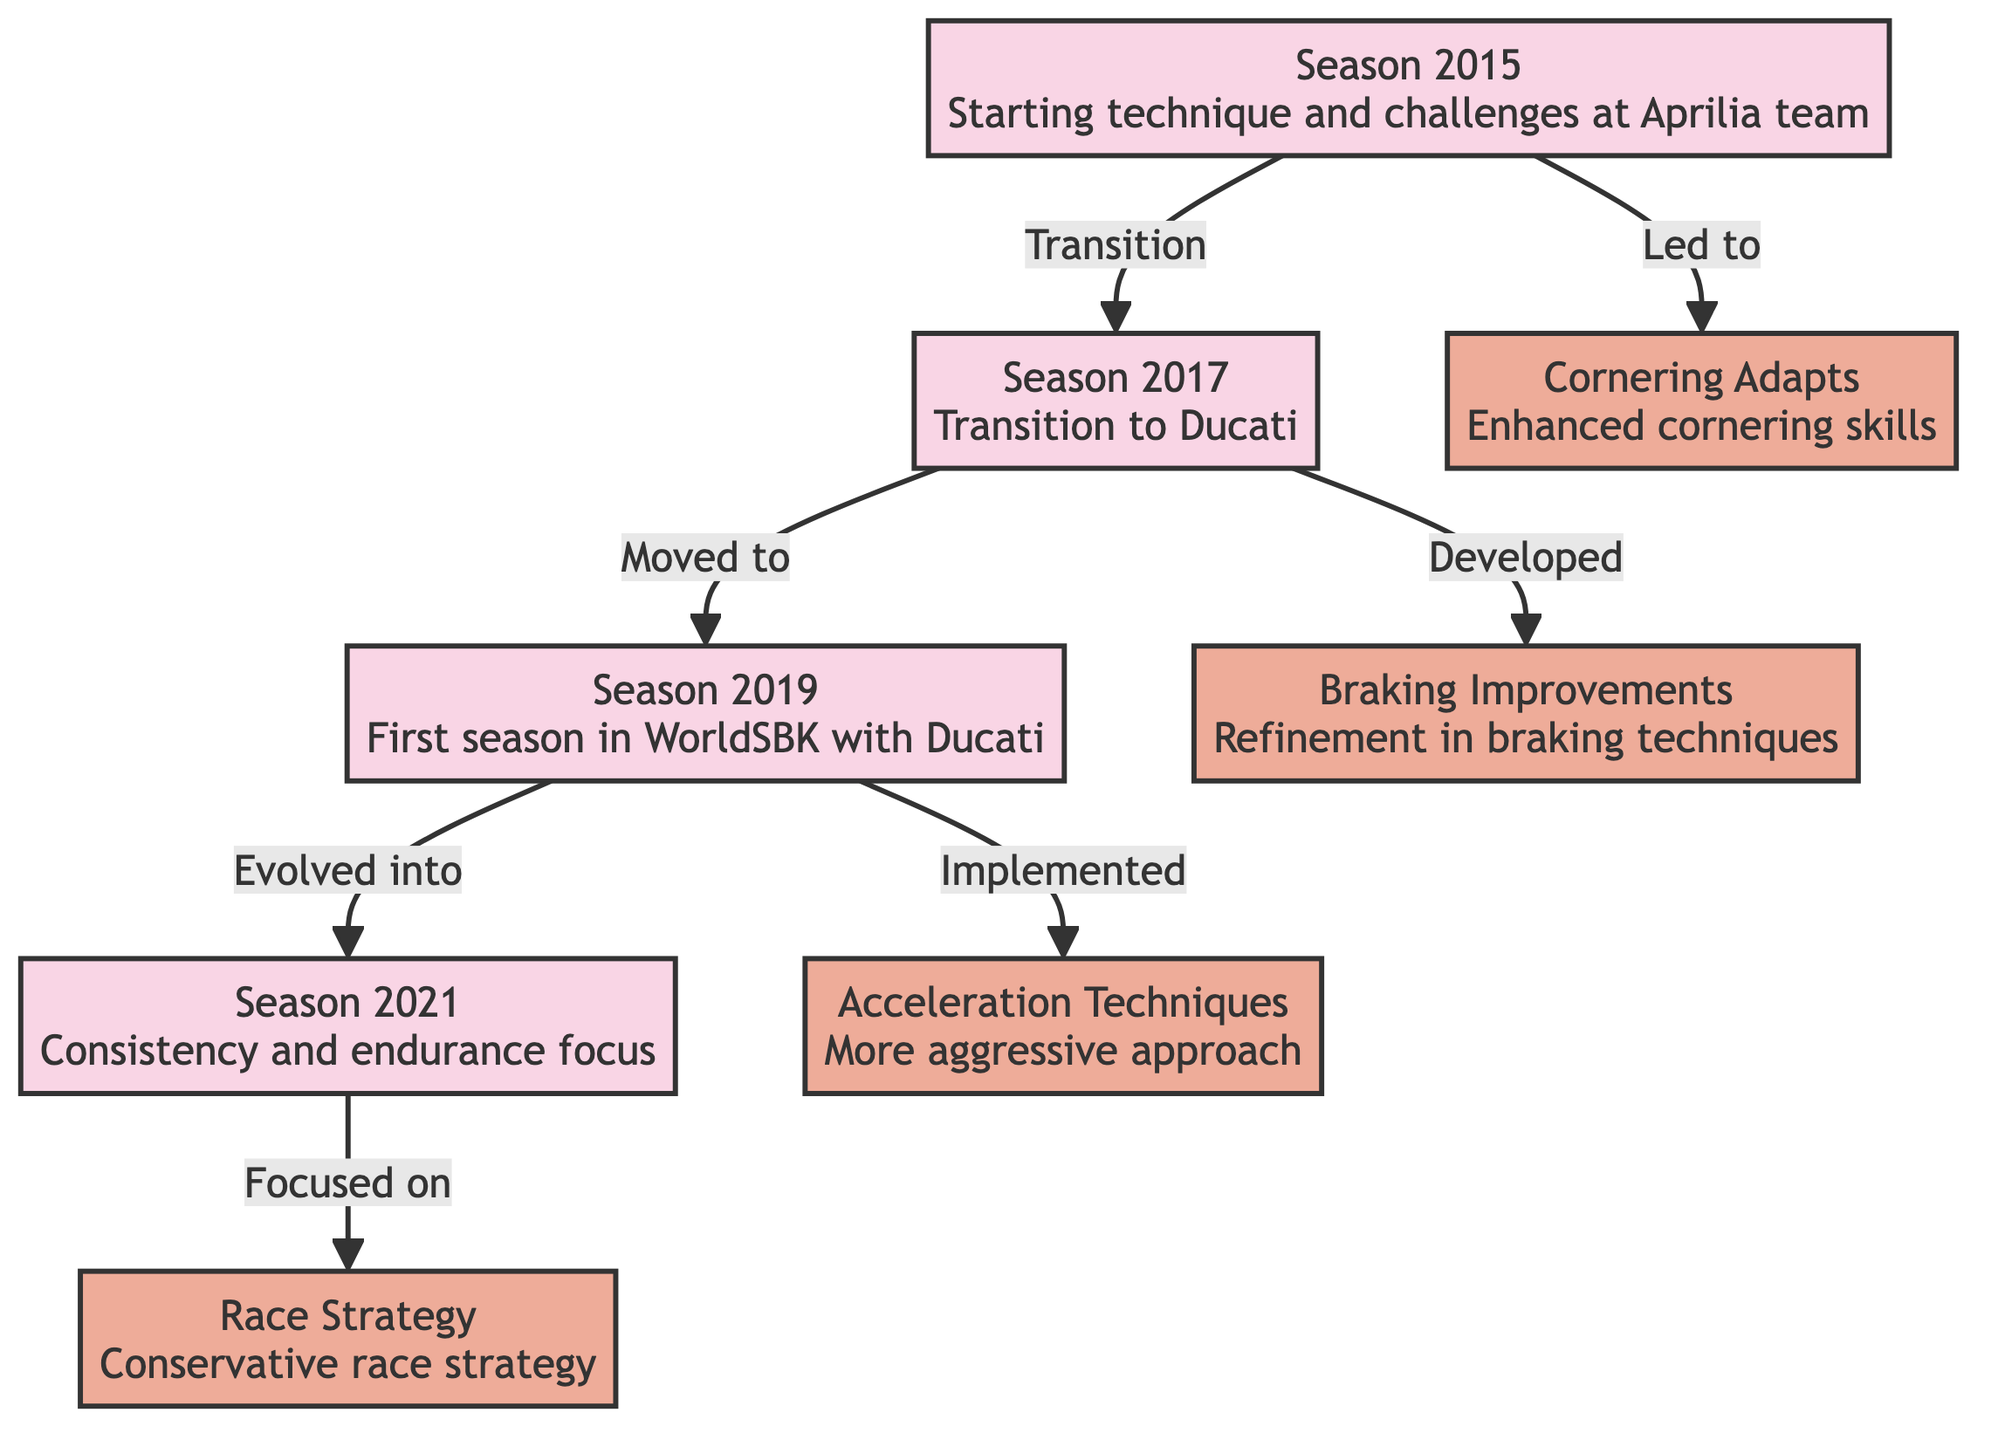What's the primary focus of Season 2015? The diagram states that Season 2015 is characterized by "Starting technique and challenges at Aprilia team". Thus, the primary focus is on the initial development and struggles faced by Bautista during this year.
Answer: Starting technique and challenges at Aprilia team How many seasons are represented in the diagram? The diagram has four distinct nodes labeled as seasons: Season 2015, Season 2017, Adaptation 2019, and Consistency 2021. Counting these gives a total of four seasons.
Answer: 4 Which technique was developed in Season 2017? The edge from Season 2017 to Braking Improvements indicates that this technique was specifically developed during that season, focusing on refinement in braking techniques.
Answer: Braking Improvements What adaptation did Álvaro Bautista implement in 2019? The arrow from Adaptation 2019 to Acceleration Techniques indicates that he implemented a more aggressive acceleration approach and a quick shift technique during that season.
Answer: Acceleration Techniques How does Consistency 2021 relate to Race Strategy? The diagram shows that Consistency 2021 focuses on Race Strategy, indicating that the development of race strategy was a direct focus stemming from efforts made during the consistency phase.
Answer: Focused on What does the term "Evolved into" imply between Adaptation 2019 and Consistency 2021? The phrase "Evolved into" signifies a progression or development from Adaptation 2019 toward Consistency 2021, meaning that the techniques and improvements made in 2019 laid the groundwork for the focus on consistency in 2021.
Answer: Evolved into In which season did Bautista transition to Ducati? The diagram identifies Season 2017 as the period where Bautista transitioned to Ducati, marking a significant change in his racing environment and techniques.
Answer: Season 2017 How did cornering skills change from Season 2015 to Adaptation 2019? Season 2015 had a node for Cornering Adapts, continuing into Adaptation 2019. This implies that improvements in cornering skills were not only initiated in 2015 but also carried over and were possibly refined or adapted in 2019.
Answer: Enhanced cornering skills 